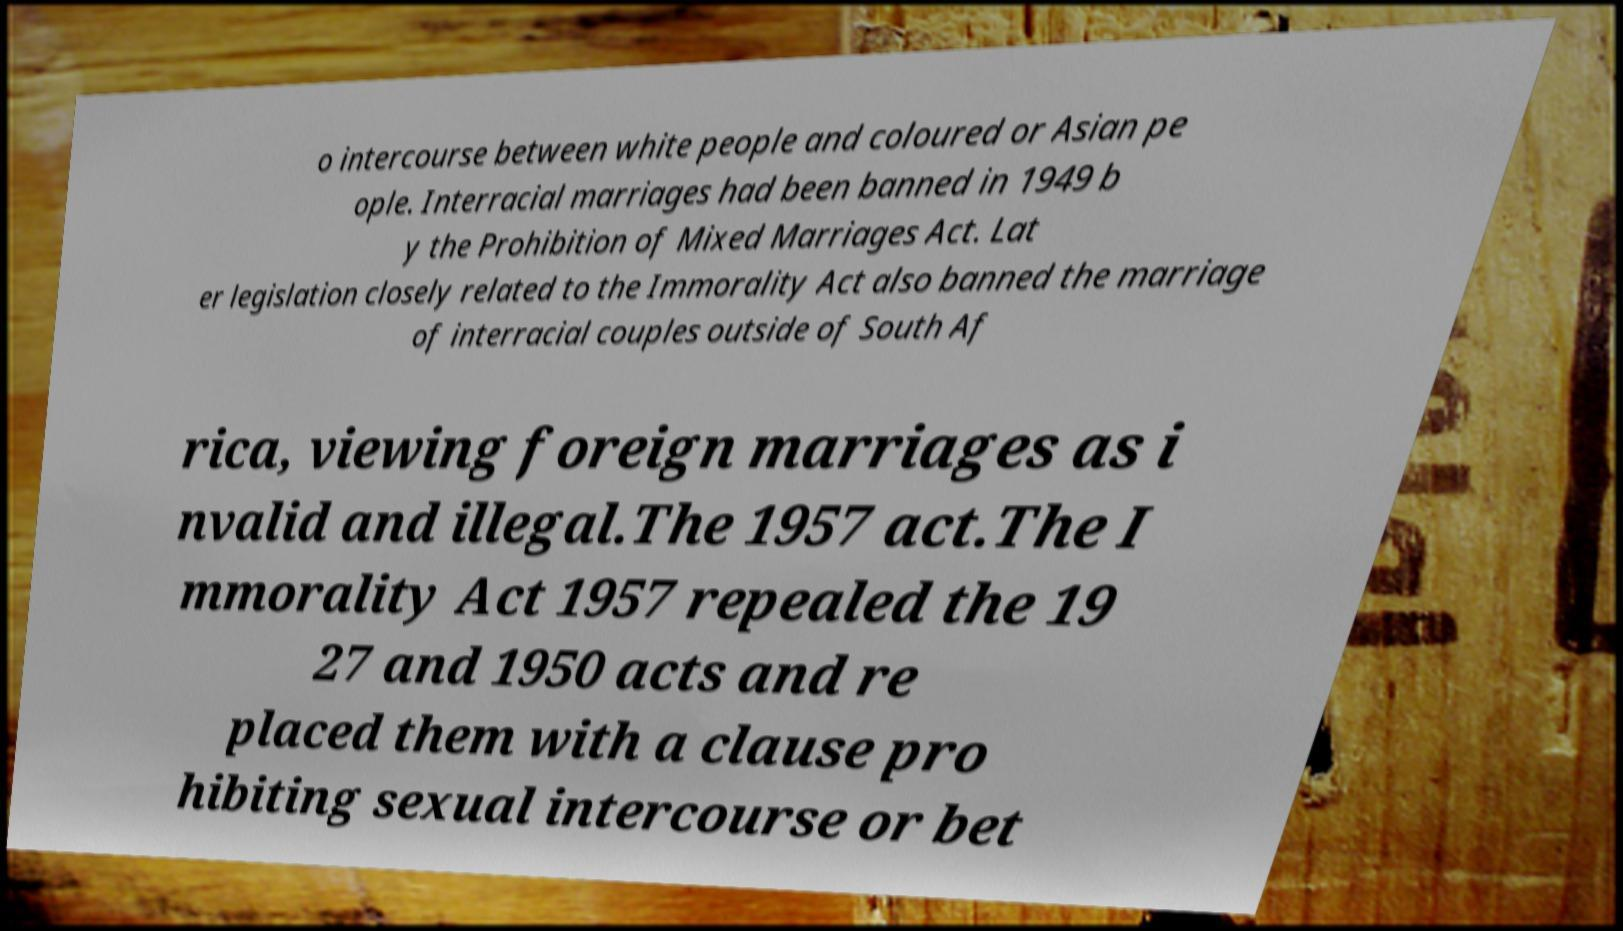Can you read and provide the text displayed in the image?This photo seems to have some interesting text. Can you extract and type it out for me? o intercourse between white people and coloured or Asian pe ople. Interracial marriages had been banned in 1949 b y the Prohibition of Mixed Marriages Act. Lat er legislation closely related to the Immorality Act also banned the marriage of interracial couples outside of South Af rica, viewing foreign marriages as i nvalid and illegal.The 1957 act.The I mmorality Act 1957 repealed the 19 27 and 1950 acts and re placed them with a clause pro hibiting sexual intercourse or bet 